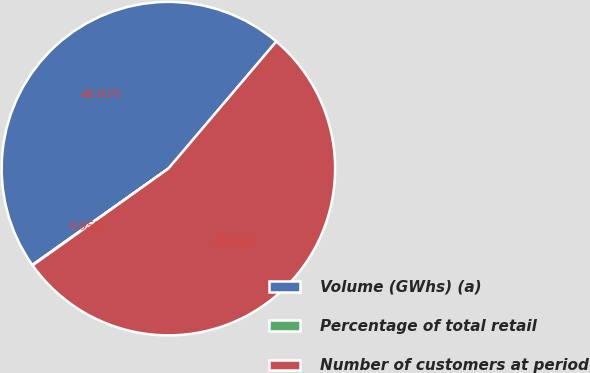<chart> <loc_0><loc_0><loc_500><loc_500><pie_chart><fcel>Volume (GWhs) (a)<fcel>Percentage of total retail<fcel>Number of customers at period<nl><fcel>46.01%<fcel>0.05%<fcel>53.94%<nl></chart> 